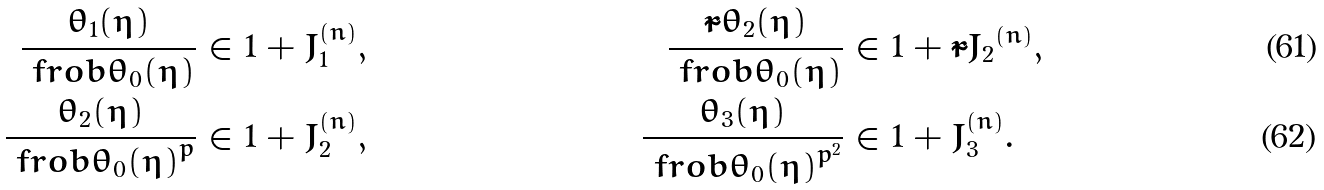<formula> <loc_0><loc_0><loc_500><loc_500>\frac { \theta _ { 1 } ( \eta ) } { \ f r o b { \theta _ { 0 } ( \eta ) } } & \in 1 + J ^ { ( n ) } _ { 1 } , & \frac { \tilde { r } { \theta _ { 2 } } ( \eta ) } { \ f r o b { \theta _ { 0 } ( \eta ) } } & \in 1 + \tilde { r } { J _ { 2 } } ^ { ( n ) } , \\ \frac { \theta _ { 2 } ( \eta ) } { \ f r o b { \theta _ { 0 } ( \eta ) } ^ { p } } & \in 1 + J ^ { ( n ) } _ { 2 } , & \frac { \theta _ { 3 } ( \eta ) } { \ f r o b { \theta _ { 0 } ( \eta ) } ^ { p ^ { 2 } } } & \in 1 + J ^ { ( n ) } _ { 3 } .</formula> 